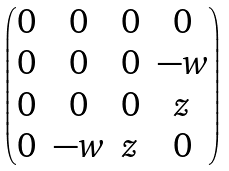<formula> <loc_0><loc_0><loc_500><loc_500>\begin{pmatrix} 0 & 0 & 0 & 0 \\ 0 & 0 & 0 & - w \\ 0 & 0 & 0 & z \\ 0 & - w & z & 0 \\ \end{pmatrix}</formula> 